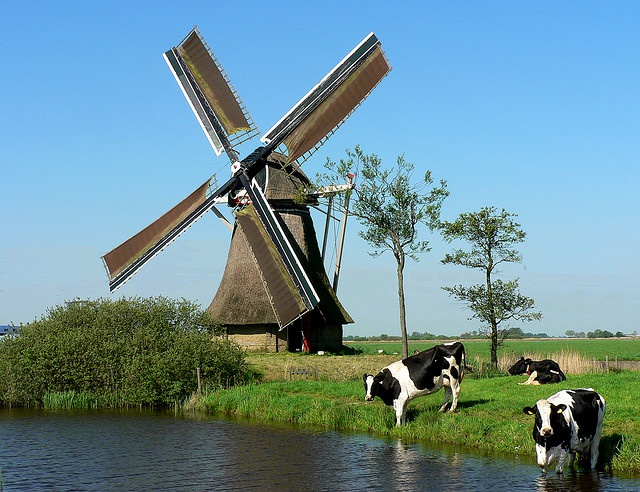Describe the objects in this image and their specific colors. I can see cow in lightblue, black, ivory, gray, and darkgreen tones, cow in lightblue, black, ivory, gray, and darkgreen tones, and cow in lightblue, black, khaki, beige, and darkgreen tones in this image. 